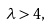<formula> <loc_0><loc_0><loc_500><loc_500>\lambda > 4 ,</formula> 